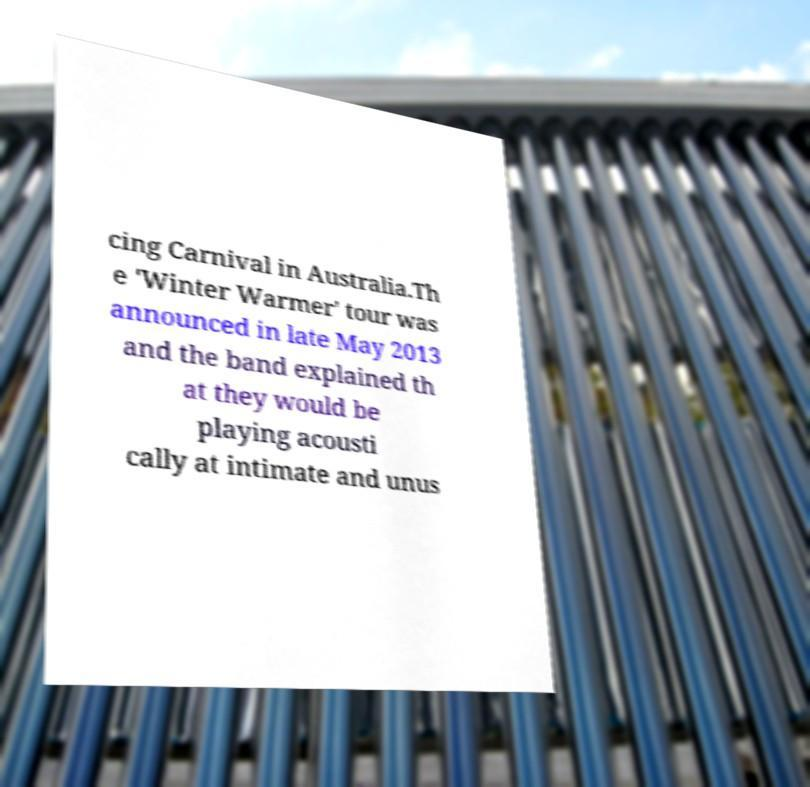Please read and relay the text visible in this image. What does it say? cing Carnival in Australia.Th e 'Winter Warmer' tour was announced in late May 2013 and the band explained th at they would be playing acousti cally at intimate and unus 